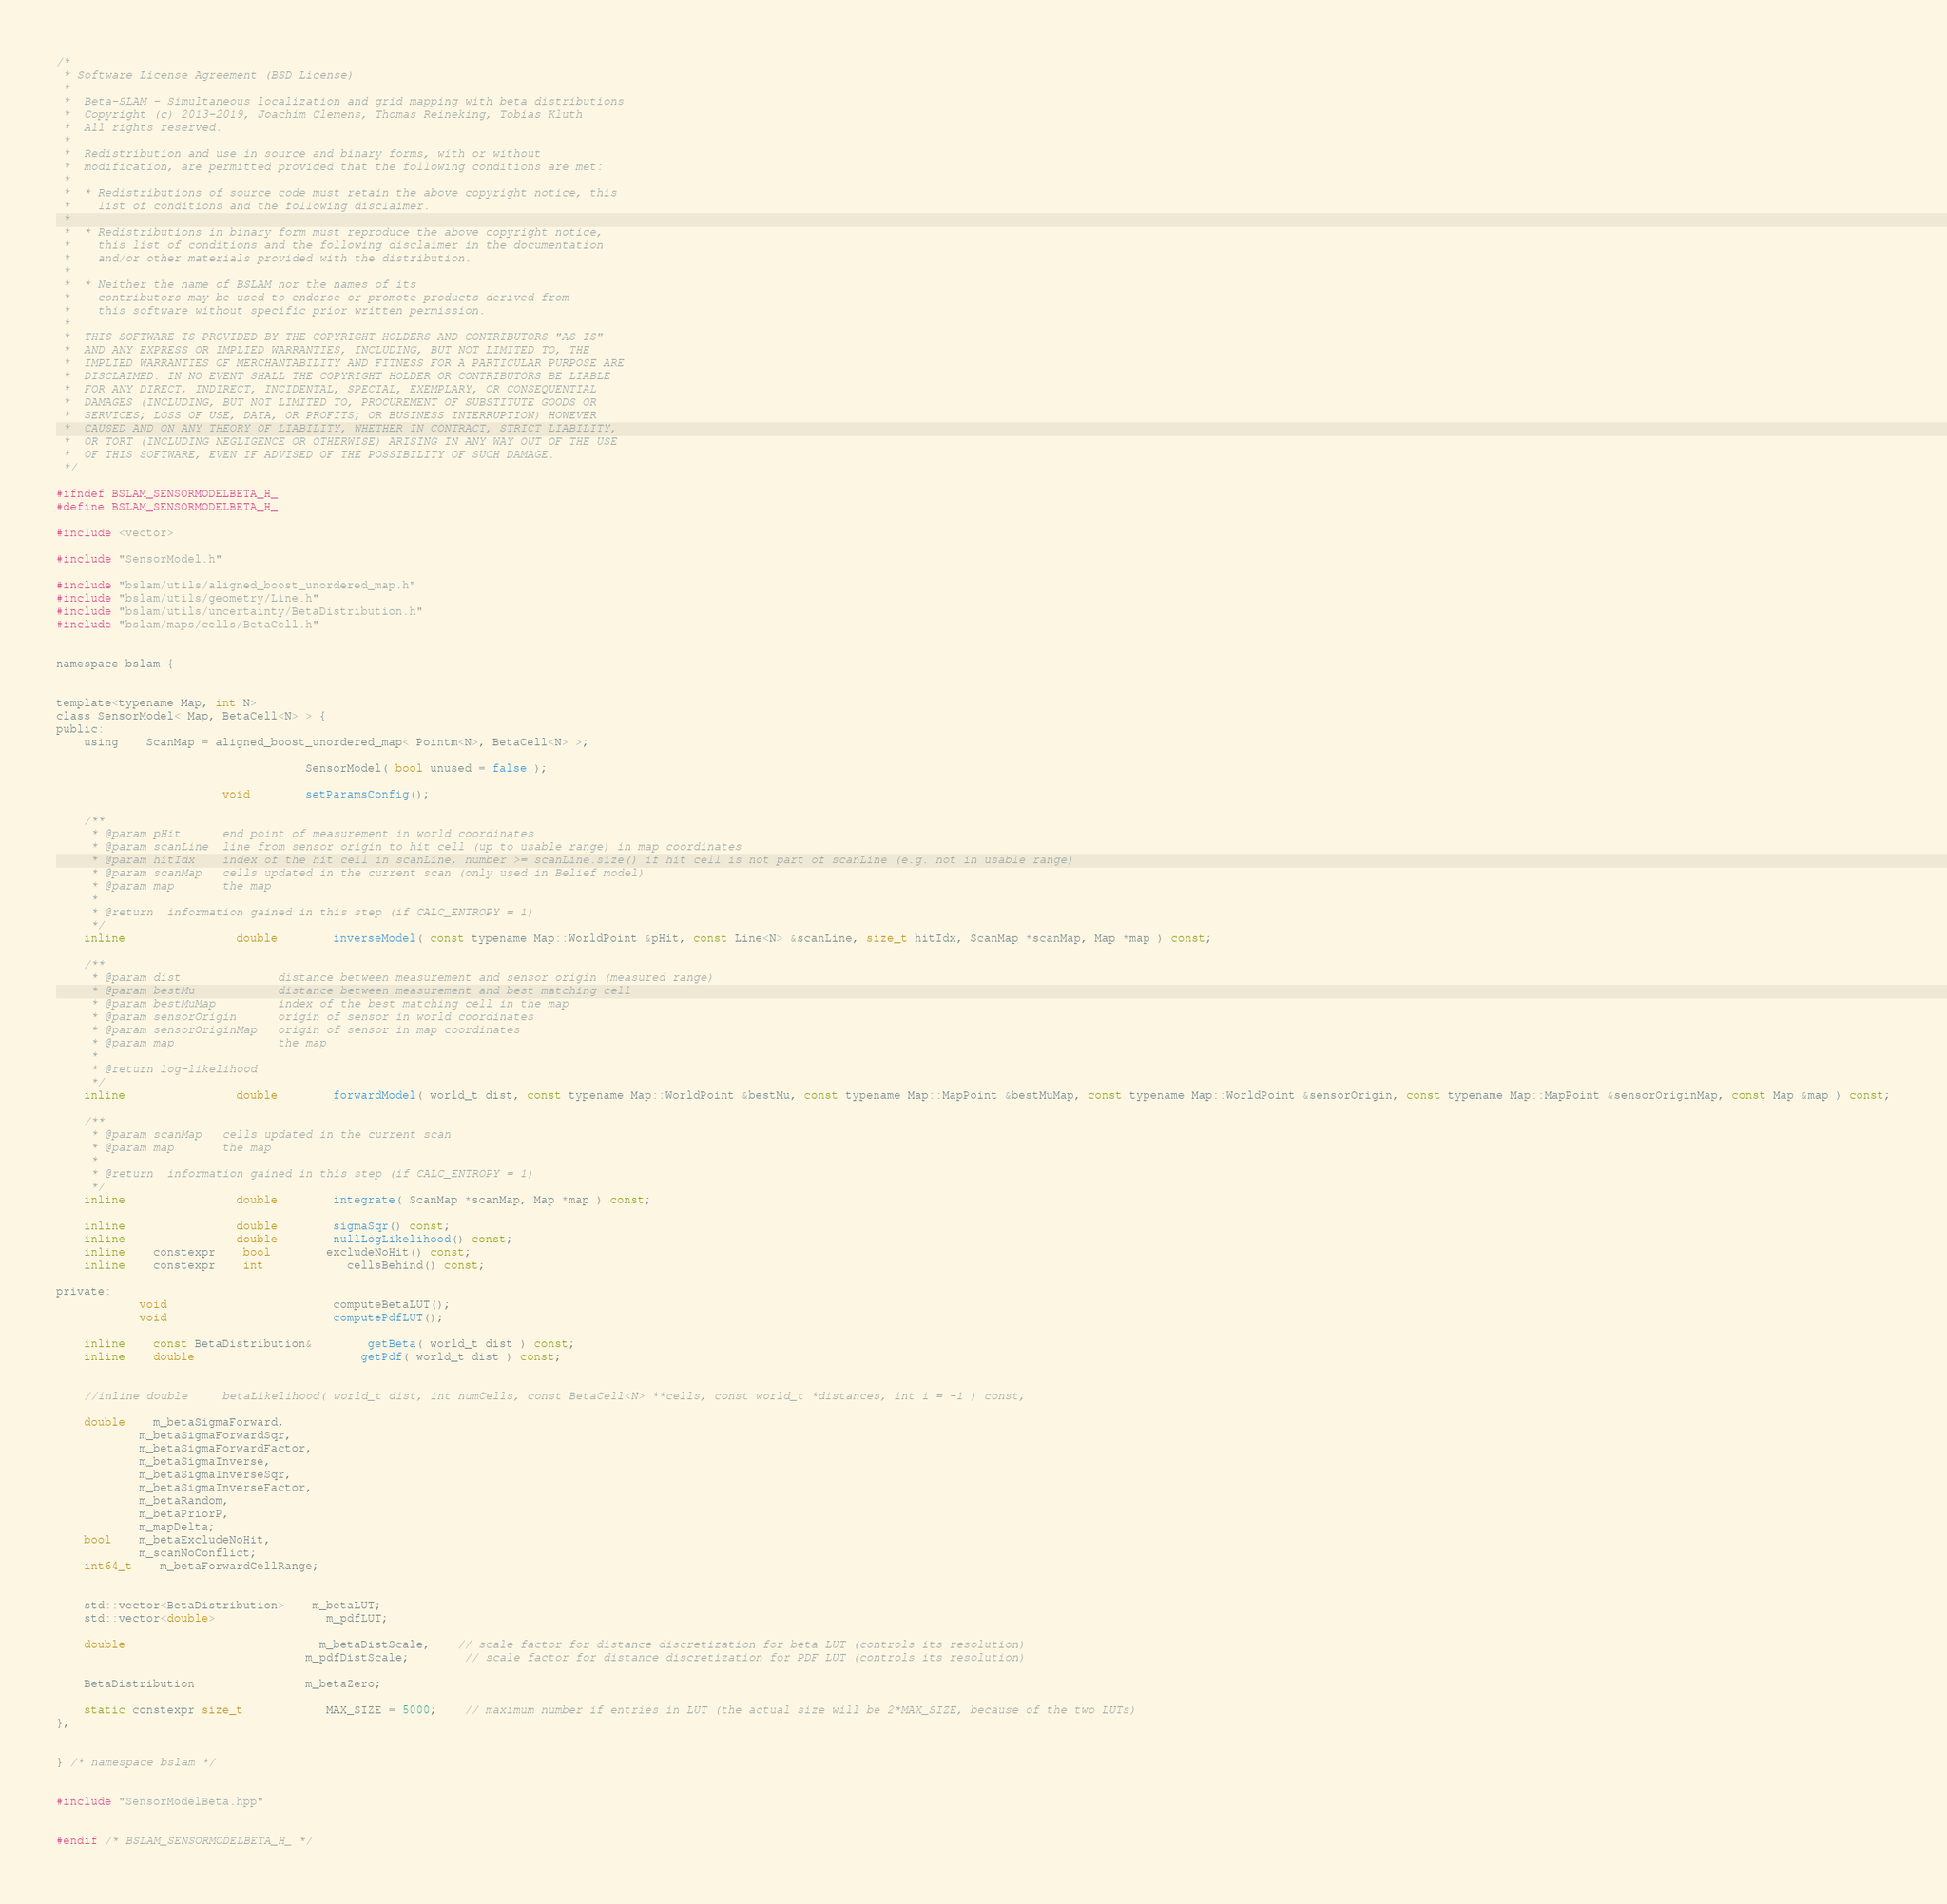<code> <loc_0><loc_0><loc_500><loc_500><_C_>/*
 * Software License Agreement (BSD License)
 *
 *  Beta-SLAM - Simultaneous localization and grid mapping with beta distributions
 *  Copyright (c) 2013-2019, Joachim Clemens, Thomas Reineking, Tobias Kluth
 *  All rights reserved.
 *
 *  Redistribution and use in source and binary forms, with or without
 *  modification, are permitted provided that the following conditions are met:
 *
 *  * Redistributions of source code must retain the above copyright notice, this
 *    list of conditions and the following disclaimer.
 *
 *  * Redistributions in binary form must reproduce the above copyright notice,
 *    this list of conditions and the following disclaimer in the documentation
 *    and/or other materials provided with the distribution.
 *
 *  * Neither the name of BSLAM nor the names of its
 *    contributors may be used to endorse or promote products derived from
 *    this software without specific prior written permission.
 *
 *  THIS SOFTWARE IS PROVIDED BY THE COPYRIGHT HOLDERS AND CONTRIBUTORS "AS IS"
 *  AND ANY EXPRESS OR IMPLIED WARRANTIES, INCLUDING, BUT NOT LIMITED TO, THE
 *  IMPLIED WARRANTIES OF MERCHANTABILITY AND FITNESS FOR A PARTICULAR PURPOSE ARE
 *  DISCLAIMED. IN NO EVENT SHALL THE COPYRIGHT HOLDER OR CONTRIBUTORS BE LIABLE
 *  FOR ANY DIRECT, INDIRECT, INCIDENTAL, SPECIAL, EXEMPLARY, OR CONSEQUENTIAL
 *  DAMAGES (INCLUDING, BUT NOT LIMITED TO, PROCUREMENT OF SUBSTITUTE GOODS OR
 *  SERVICES; LOSS OF USE, DATA, OR PROFITS; OR BUSINESS INTERRUPTION) HOWEVER
 *  CAUSED AND ON ANY THEORY OF LIABILITY, WHETHER IN CONTRACT, STRICT LIABILITY,
 *  OR TORT (INCLUDING NEGLIGENCE OR OTHERWISE) ARISING IN ANY WAY OUT OF THE USE
 *  OF THIS SOFTWARE, EVEN IF ADVISED OF THE POSSIBILITY OF SUCH DAMAGE.
 */

#ifndef BSLAM_SENSORMODELBETA_H_
#define BSLAM_SENSORMODELBETA_H_

#include <vector>

#include "SensorModel.h"

#include "bslam/utils/aligned_boost_unordered_map.h"
#include "bslam/utils/geometry/Line.h"
#include "bslam/utils/uncertainty/BetaDistribution.h"
#include "bslam/maps/cells/BetaCell.h"


namespace bslam {


template<typename Map, int N>
class SensorModel< Map, BetaCell<N> > {
public:
	using	ScanMap = aligned_boost_unordered_map< Pointm<N>, BetaCell<N> >;

									SensorModel( bool unused = false );

						void		setParamsConfig();

	/**
	 * @param pHit		end point of measurement in world coordinates
	 * @param scanLine	line from sensor origin to hit cell (up to usable range) in map coordinates
	 * @param hitIdx	index of the hit cell in scanLine, number >= scanLine.size() if hit cell is not part of scanLine (e.g. not in usable range)
	 * @param scanMap	cells updated in the current scan (only used in Belief model)
	 * @param map		the map
	 *
	 * @return	information gained in this step (if CALC_ENTROPY = 1)
	 */
	inline				double 		inverseModel( const typename Map::WorldPoint &pHit, const Line<N> &scanLine, size_t hitIdx, ScanMap *scanMap, Map *map ) const;

	/**
	 * @param dist				distance between measurement and sensor origin (measured range)
	 * @param bestMu			distance between measurement and best matching cell
	 * @param bestMuMap			index of the best matching cell in the map
	 * @param sensorOrigin		origin of sensor in world coordinates
	 * @param sensorOriginMap 	origin of sensor in map coordinates
	 * @param map				the map
	 *
	 * @return log-likelihood
	 */
	inline				double 		forwardModel( world_t dist, const typename Map::WorldPoint &bestMu, const typename Map::MapPoint &bestMuMap, const typename Map::WorldPoint &sensorOrigin, const typename Map::MapPoint &sensorOriginMap, const Map &map ) const;

	/**
	 * @param scanMap	cells updated in the current scan
	 * @param map		the map
	 *
	 * @return	information gained in this step (if CALC_ENTROPY = 1)
	 */
	inline				double		integrate( ScanMap *scanMap, Map *map ) const;

	inline				double		sigmaSqr() const;
	inline				double		nullLogLikelihood() const;
	inline	constexpr	bool		excludeNoHit() const;
	inline	constexpr	int			cellsBehind() const;

private:
			void						computeBetaLUT();
			void						computePdfLUT();

	inline	const BetaDistribution&		getBeta( world_t dist ) const;
	inline	double						getPdf( world_t dist ) const;


	//inline double 	betaLikelihood( world_t dist, int numCells, const BetaCell<N> **cells, const world_t *distances, int i = -1 ) const;

	double	m_betaSigmaForward,
			m_betaSigmaForwardSqr,
			m_betaSigmaForwardFactor,
			m_betaSigmaInverse,
			m_betaSigmaInverseSqr,
			m_betaSigmaInverseFactor,
			m_betaRandom,
			m_betaPriorP,
			m_mapDelta;
	bool	m_betaExcludeNoHit,
			m_scanNoConflict;
	int64_t	m_betaForwardCellRange;


	std::vector<BetaDistribution>	m_betaLUT;
	std::vector<double>				m_pdfLUT;

	double							m_betaDistScale,	// scale factor for distance discretization for beta LUT (controls its resolution)
									m_pdfDistScale;		// scale factor for distance discretization for PDF LUT (controls its resolution)

	BetaDistribution				m_betaZero;

	static constexpr size_t			MAX_SIZE = 5000;	// maximum number if entries in LUT (the actual size will be 2*MAX_SIZE, because of the two LUTs)
};


} /* namespace bslam */


#include "SensorModelBeta.hpp"


#endif /* BSLAM_SENSORMODELBETA_H_ */
</code> 